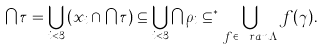<formula> <loc_0><loc_0><loc_500><loc_500>\bigcap \tau = \bigcup _ { i < 3 } \left ( x _ { i } \cap \bigcap \tau \right ) \subseteq \bigcup _ { i < 3 } \bigcap \rho _ { i } \subseteq ^ { * } \bigcup _ { f \in \ r a n \Lambda } f ( \gamma ) .</formula> 